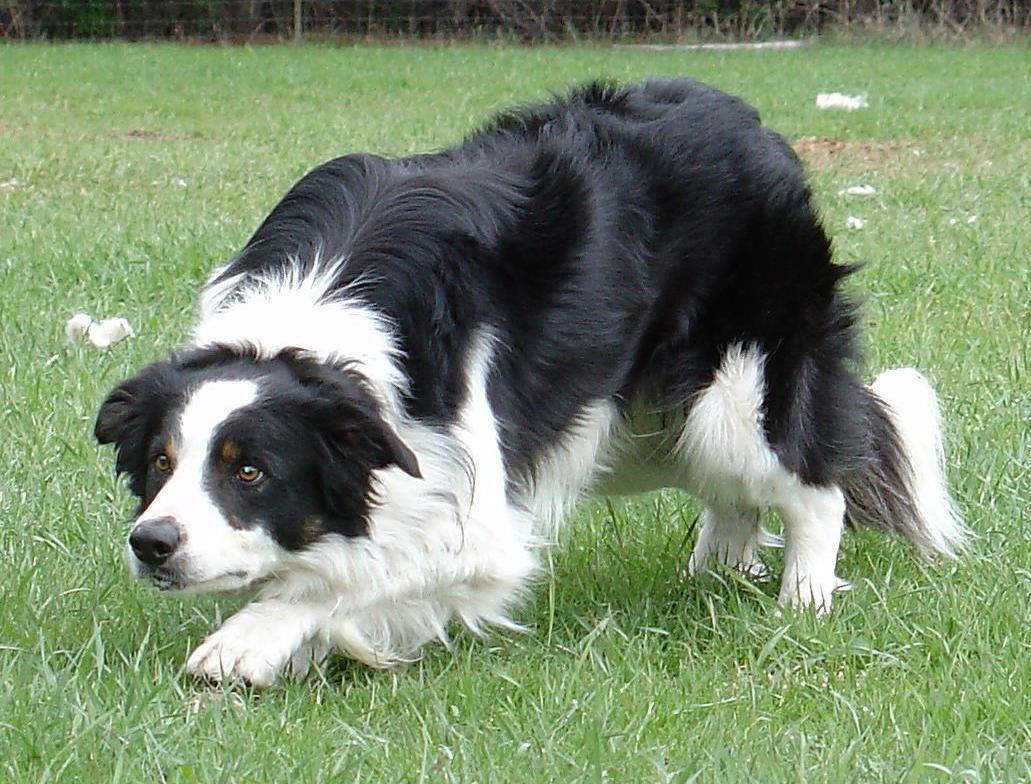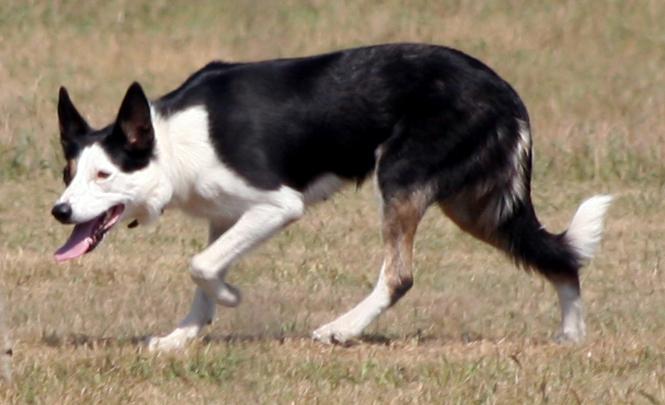The first image is the image on the left, the second image is the image on the right. Examine the images to the left and right. Is the description "One of the dogs is lying on grass with its head up." accurate? Answer yes or no. No. The first image is the image on the left, the second image is the image on the right. Considering the images on both sides, is "There is one border calling laying down in the grass." valid? Answer yes or no. No. 